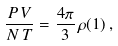Convert formula to latex. <formula><loc_0><loc_0><loc_500><loc_500>\frac { P \, V } { N \, T } = \frac { 4 \pi } 3 \, \rho ( 1 ) \, ,</formula> 